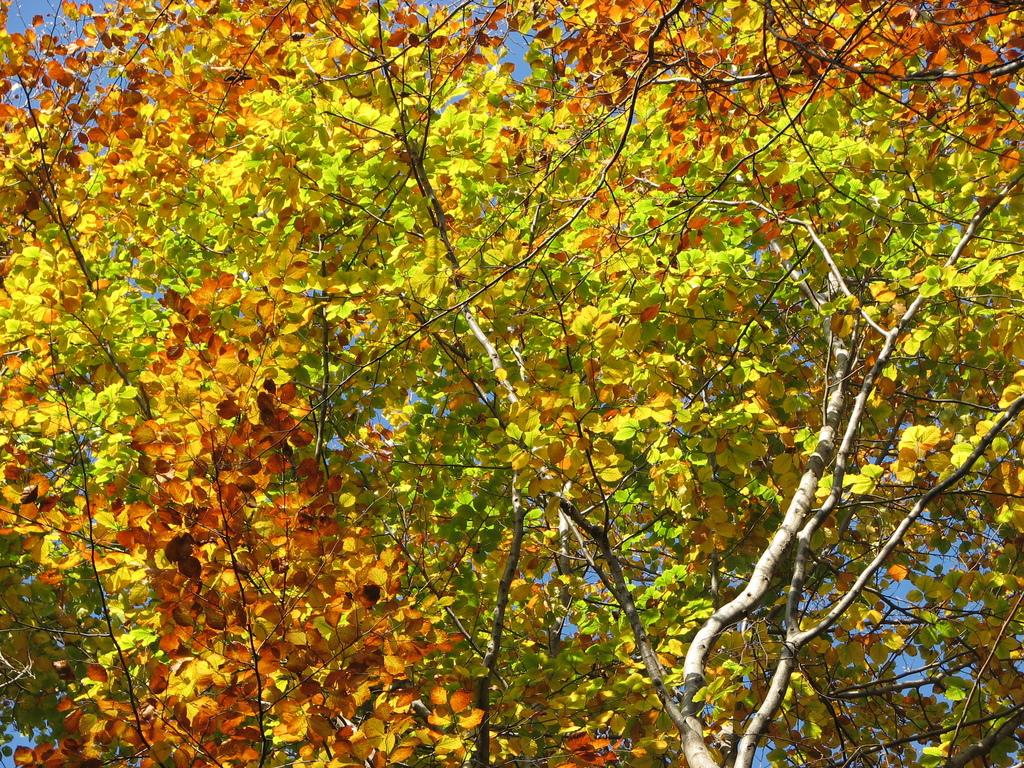Where was the image taken? The image was taken outdoors. What can be seen in the background of the image? The sky is visible in the background of the image. What is located in the middle of the image? There are trees in the middle of the image. What are the main parts of the trees in the image? The trees have branches, stems, and leaves. What advice is written in the notebook that is visible in the image? There is no notebook present in the image, so no advice can be seen. 